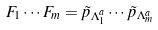Convert formula to latex. <formula><loc_0><loc_0><loc_500><loc_500>F _ { 1 } \cdots F _ { m } = \tilde { p } _ { \Lambda _ { 1 } ^ { a } } \cdots \tilde { p } _ { \Lambda _ { m } ^ { a } }</formula> 